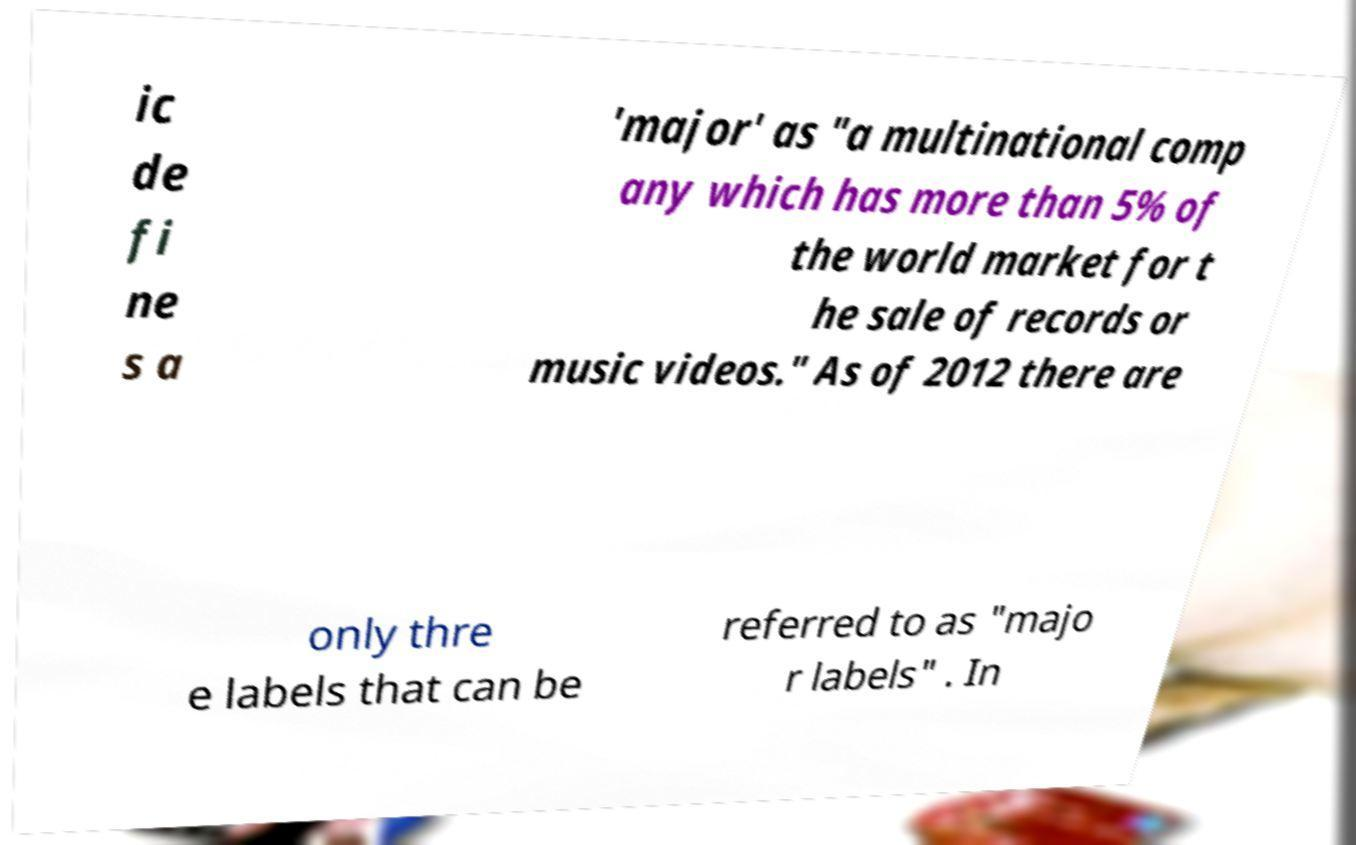Could you assist in decoding the text presented in this image and type it out clearly? ic de fi ne s a 'major' as "a multinational comp any which has more than 5% of the world market for t he sale of records or music videos." As of 2012 there are only thre e labels that can be referred to as "majo r labels" . In 